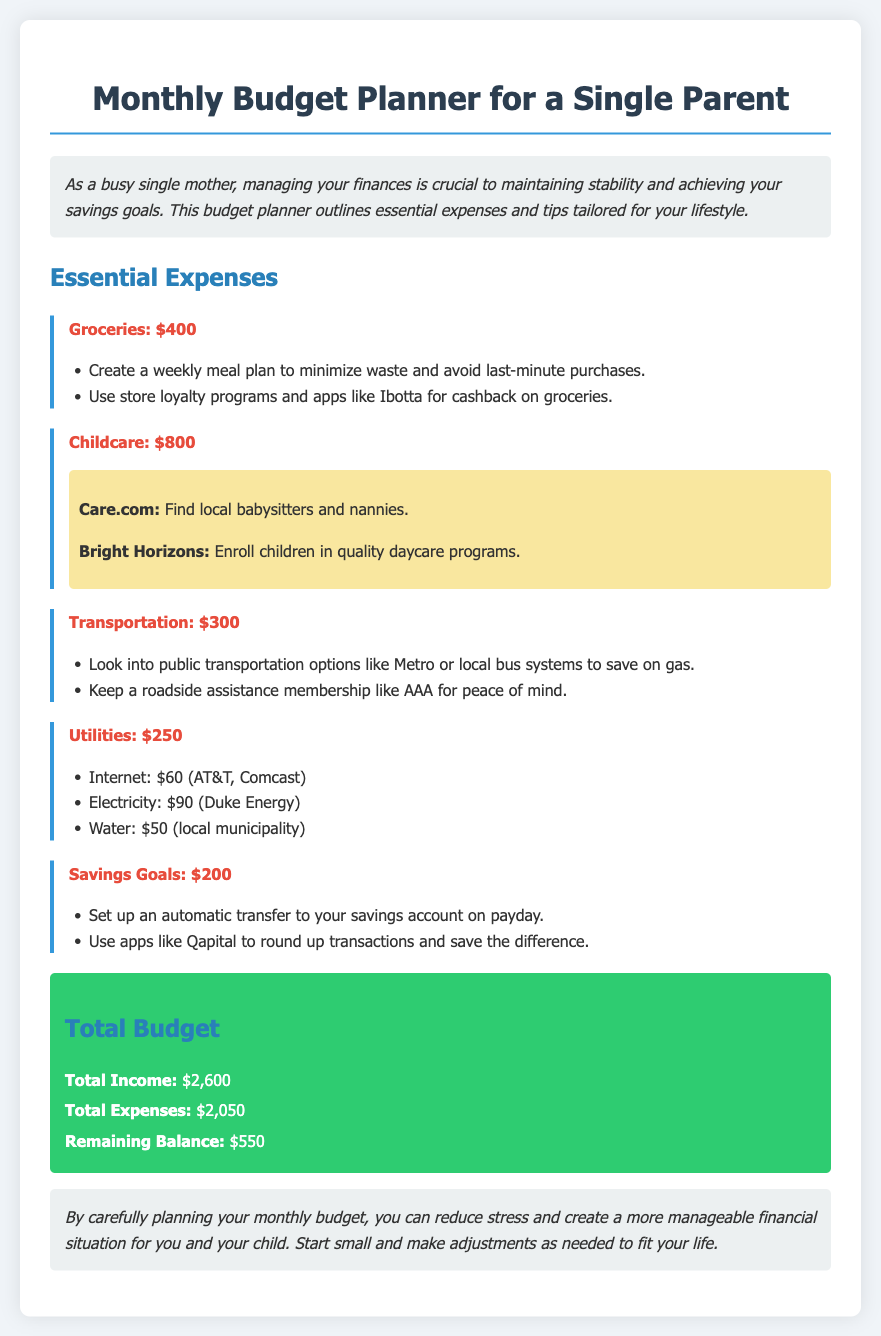What is the total income? The total income is presented clearly in the document, which is $2,600.
Answer: $2,600 How much is allocated for groceries? The document specifies the grocery expense, which is $400.
Answer: $400 What is the expense for childcare? The amount dedicated to childcare is $800, according to the document.
Answer: $800 What are the suggested resources for childcare? The document lists resources such as Care.com and Bright Horizons for finding childcare.
Answer: Care.com and Bright Horizons What is the remaining balance after expenses? The remaining balance is calculated by subtracting total expenses from total income, which is $550.
Answer: $550 What expense category has the highest cost? The highest cost category in the expense list is childcare, which is $800.
Answer: Childcare What is one way to save on transportation costs? The document suggests looking into public transportation options to save on gas.
Answer: Public transportation What is the amount set for savings goals? The savings goals have a set amount of $200 in the document.
Answer: $200 What is included in the utilities expense? The utilities expense includes internet, electricity, and water costs.
Answer: Internet, electricity, and water 